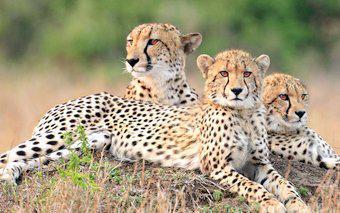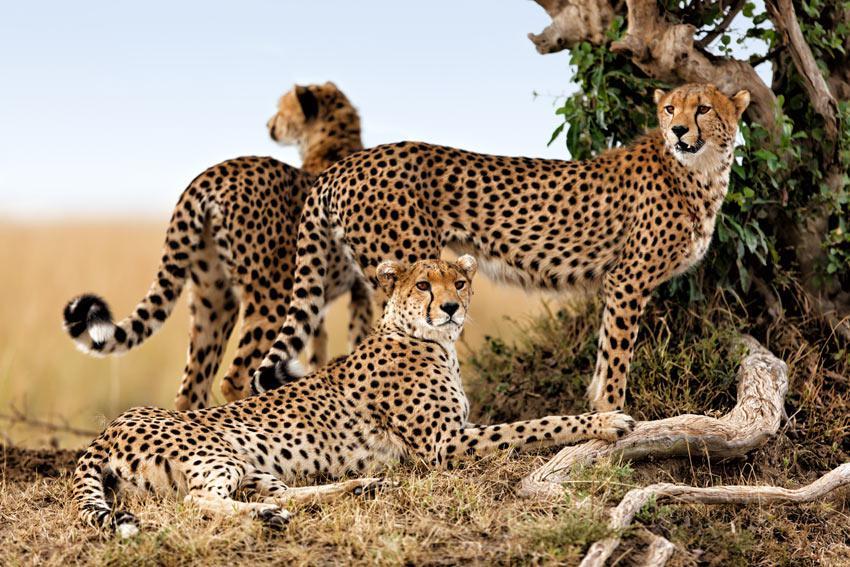The first image is the image on the left, the second image is the image on the right. Considering the images on both sides, is "Each image contains three spotted cats, and at least some of the cats are not reclining." valid? Answer yes or no. Yes. 